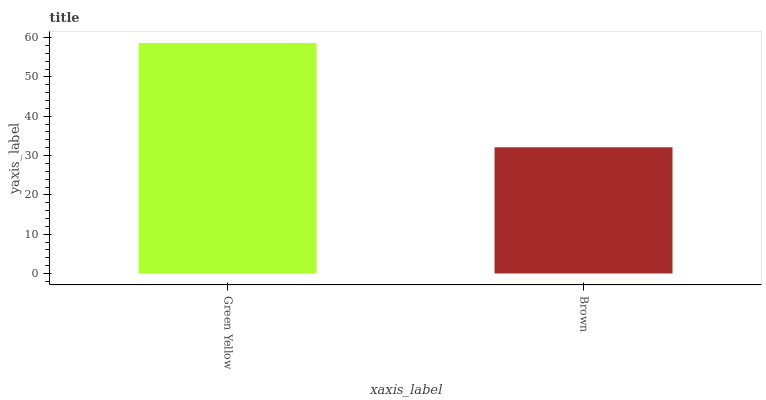Is Brown the maximum?
Answer yes or no. No. Is Green Yellow greater than Brown?
Answer yes or no. Yes. Is Brown less than Green Yellow?
Answer yes or no. Yes. Is Brown greater than Green Yellow?
Answer yes or no. No. Is Green Yellow less than Brown?
Answer yes or no. No. Is Green Yellow the high median?
Answer yes or no. Yes. Is Brown the low median?
Answer yes or no. Yes. Is Brown the high median?
Answer yes or no. No. Is Green Yellow the low median?
Answer yes or no. No. 